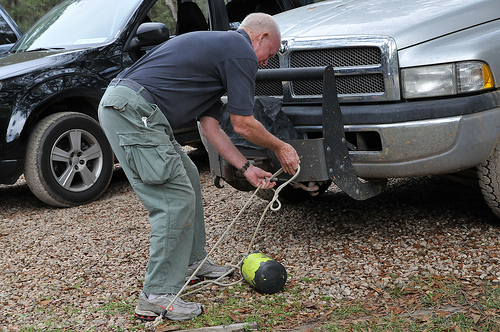Is the man to the left or to the right of the truck in this image? The man is positioned to the left of the truck, engaging actively with a rope tied to a watermelon. 